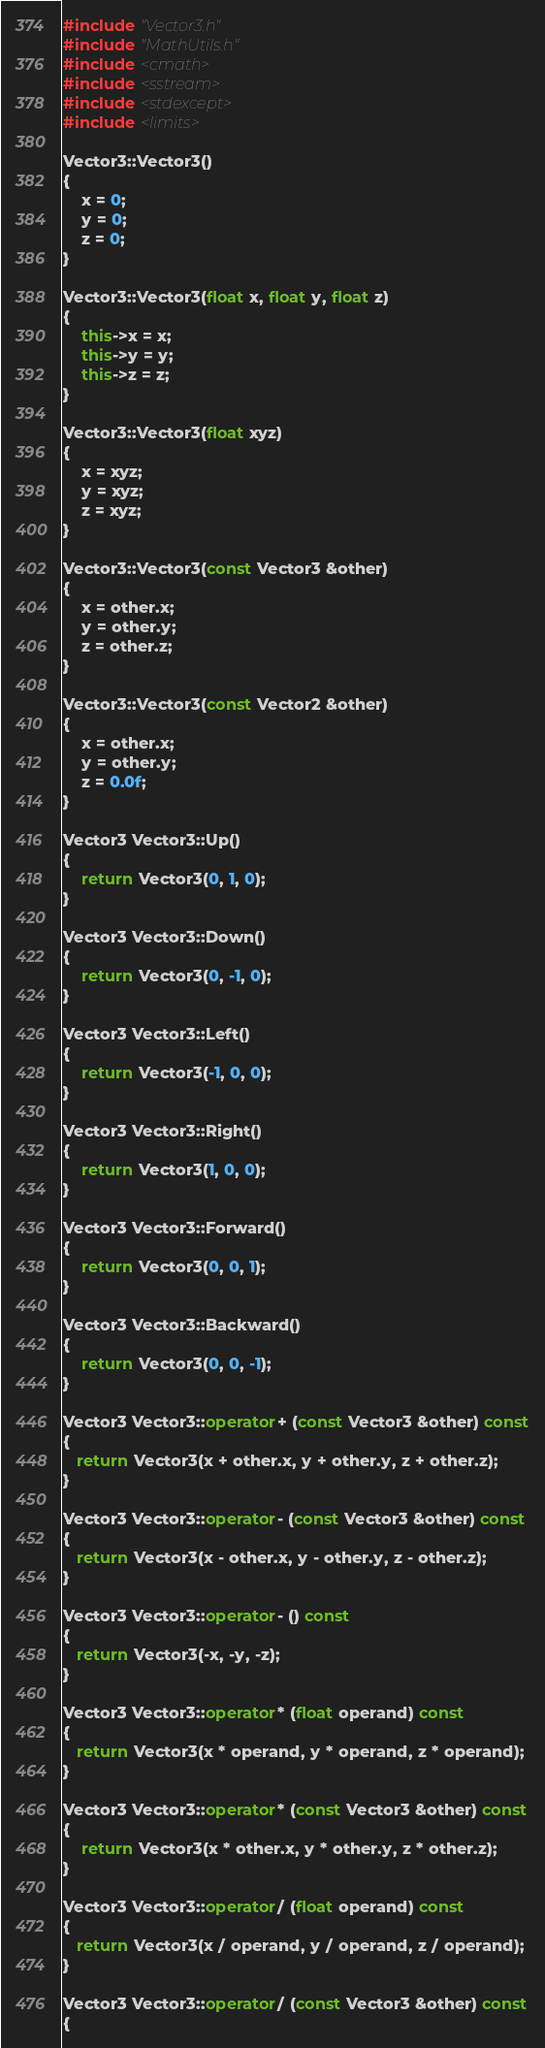<code> <loc_0><loc_0><loc_500><loc_500><_C++_>
#include "Vector3.h"
#include "MathUtils.h"
#include <cmath>
#include <sstream>
#include <stdexcept>
#include <limits>

Vector3::Vector3()
{
	x = 0;
	y = 0;
	z = 0;
}

Vector3::Vector3(float x, float y, float z)
{
	this->x = x;
	this->y = y;
	this->z = z;
}

Vector3::Vector3(float xyz)
{
	x = xyz;
	y = xyz;
	z = xyz;
}

Vector3::Vector3(const Vector3 &other)
{
	x = other.x;
	y = other.y;
	z = other.z;
}

Vector3::Vector3(const Vector2 &other)
{
	x = other.x;
	y = other.y;
	z = 0.0f;
}

Vector3 Vector3::Up()
{
	return Vector3(0, 1, 0);
}

Vector3 Vector3::Down()
{
	return Vector3(0, -1, 0);
}

Vector3 Vector3::Left()
{
	return Vector3(-1, 0, 0);
}

Vector3 Vector3::Right()
{
	return Vector3(1, 0, 0);
}

Vector3 Vector3::Forward()
{
	return Vector3(0, 0, 1);
}

Vector3 Vector3::Backward()
{
	return Vector3(0, 0, -1);
}

Vector3 Vector3::operator+ (const Vector3 &other) const
{
   return Vector3(x + other.x, y + other.y, z + other.z);
}

Vector3 Vector3::operator- (const Vector3 &other) const
{
   return Vector3(x - other.x, y - other.y, z - other.z);
}

Vector3 Vector3::operator- () const
{
   return Vector3(-x, -y, -z);
}

Vector3 Vector3::operator* (float operand) const
{
   return Vector3(x * operand, y * operand, z * operand);
}

Vector3 Vector3::operator* (const Vector3 &other) const
{
	return Vector3(x * other.x, y * other.y, z * other.z);
}

Vector3 Vector3::operator/ (float operand) const
{
   return Vector3(x / operand, y / operand, z / operand);
}

Vector3 Vector3::operator/ (const Vector3 &other) const
{</code> 